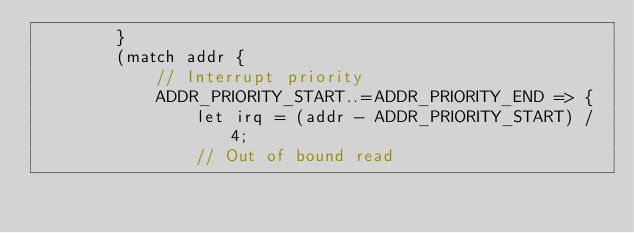<code> <loc_0><loc_0><loc_500><loc_500><_Rust_>        }
        (match addr {
            // Interrupt priority
            ADDR_PRIORITY_START..=ADDR_PRIORITY_END => {
                let irq = (addr - ADDR_PRIORITY_START) / 4;
                // Out of bound read</code> 